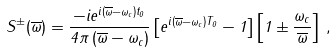Convert formula to latex. <formula><loc_0><loc_0><loc_500><loc_500>S ^ { \pm } ( \overline { \omega } ) = \frac { - i { e } ^ { i \left ( \overline { \omega } - \omega _ { c } \right ) t _ { 0 } } } { 4 \pi \left ( \overline { \omega } - \omega _ { c } \right ) } \left [ { e } ^ { i \left ( \overline { \omega } - \omega _ { c } \right ) T _ { 0 } } - 1 \right ] \left [ 1 \pm \frac { \omega _ { c } } { \overline { \omega } } \right ] \, ,</formula> 